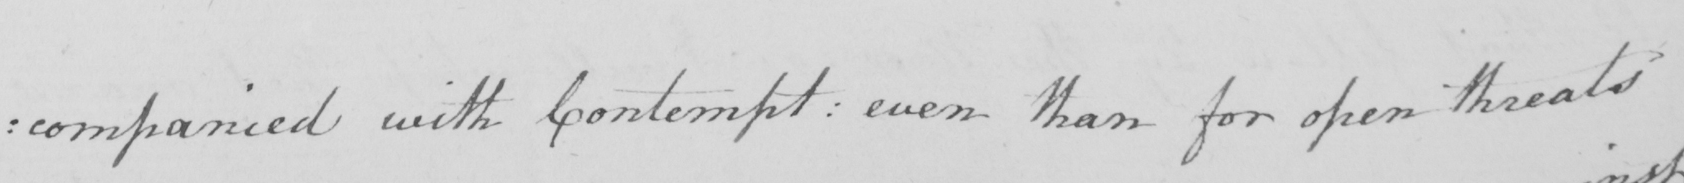What text is written in this handwritten line? companied with Contempt :  even than for open threats 